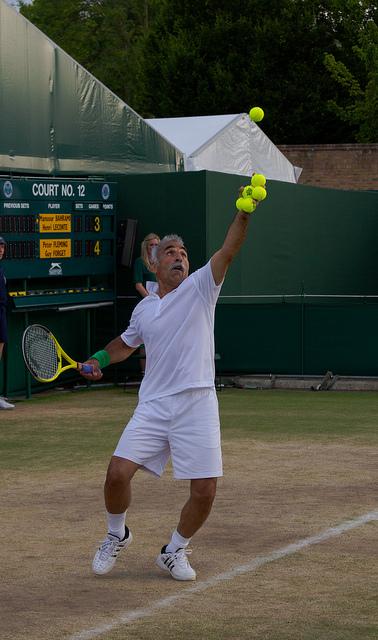Is the man wearing a hat?
Answer briefly. No. Where is the ball?
Keep it brief. Air. What color is the man's outfit?
Keep it brief. White. What color is the person's hair?
Be succinct. Gray. How many sets has this man played?
Short answer required. 7. How many balls is this tennis player throwing up?
Answer briefly. 5. 